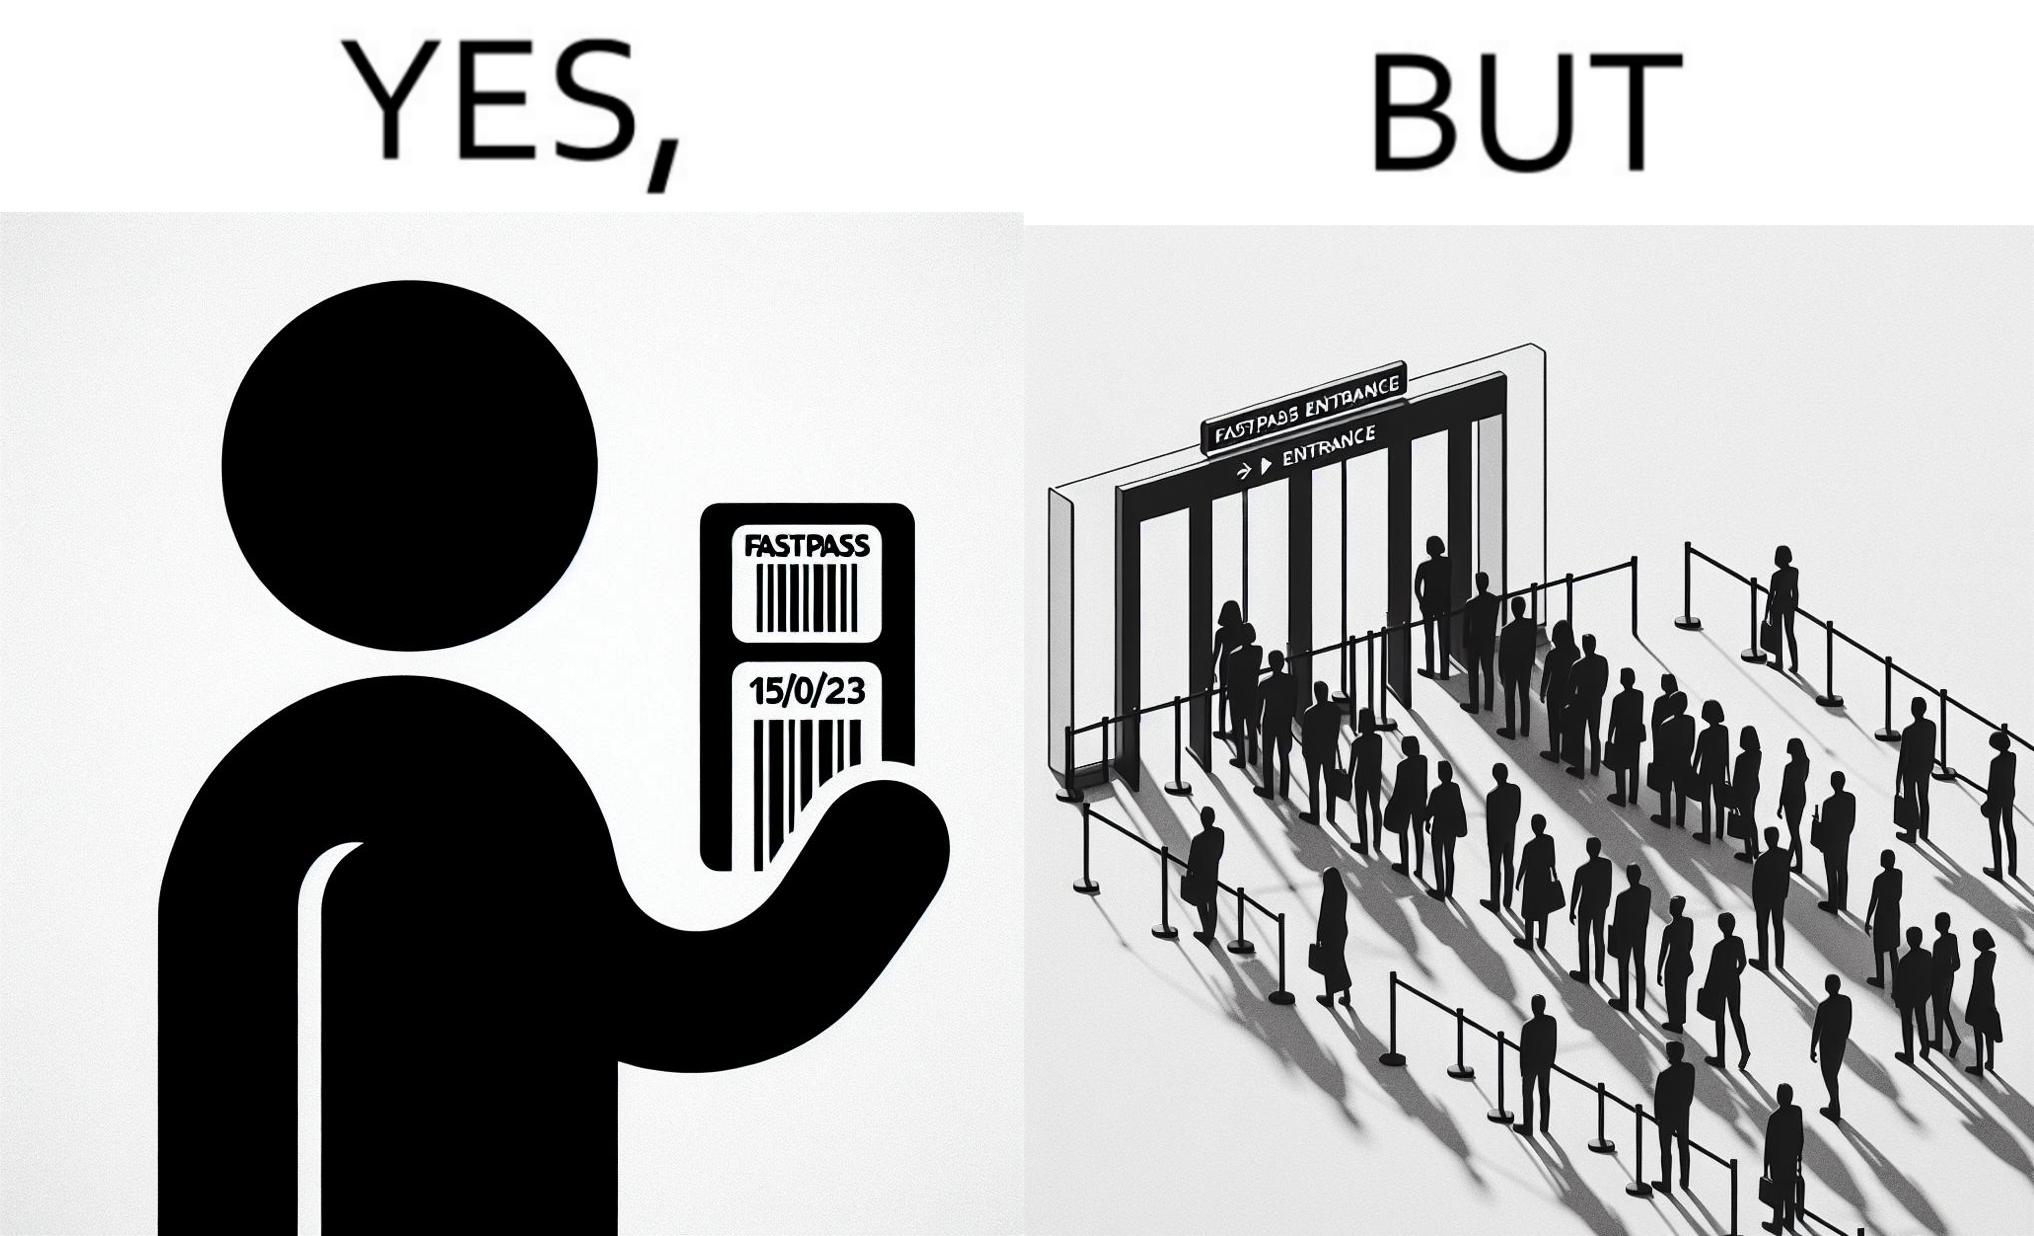Describe the satirical element in this image. The image is ironic, because fast pass entrance was meant for people to pass the gate fast but as more no. of people bought the pass due to which the queue has become longer and it becomes slow and time consuming 